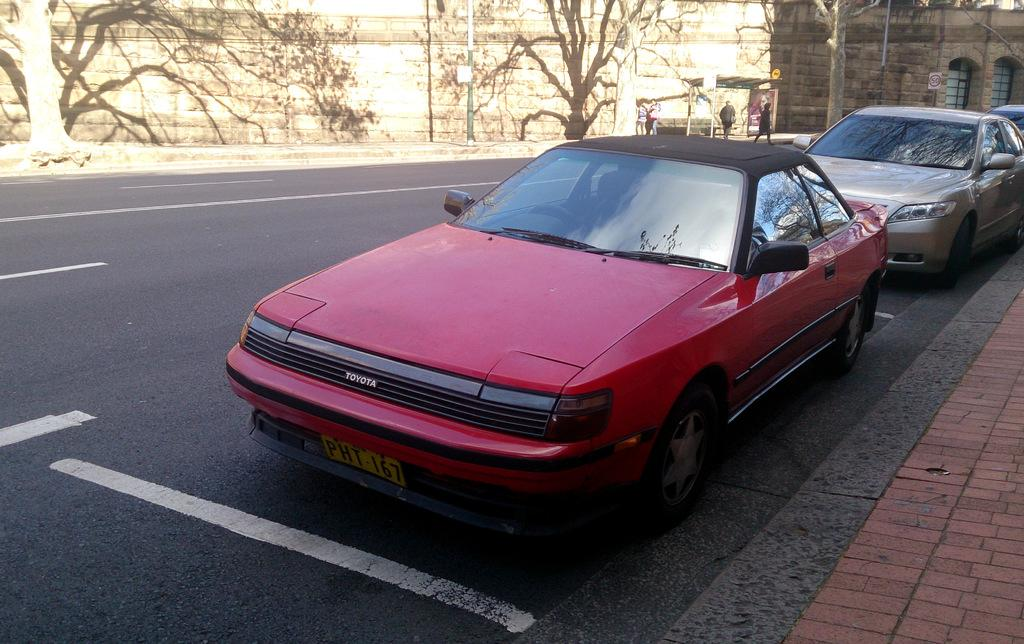What can be seen on the road in the image? There are cars on the road in the image. What is visible in the background of the image? There is a wall and trees in the background of the image. Are there any people visible in the image? Yes, there are people in the background of the image. How many apples are hanging from the trees in the image? There are no apples visible in the image; only trees are present in the background. 